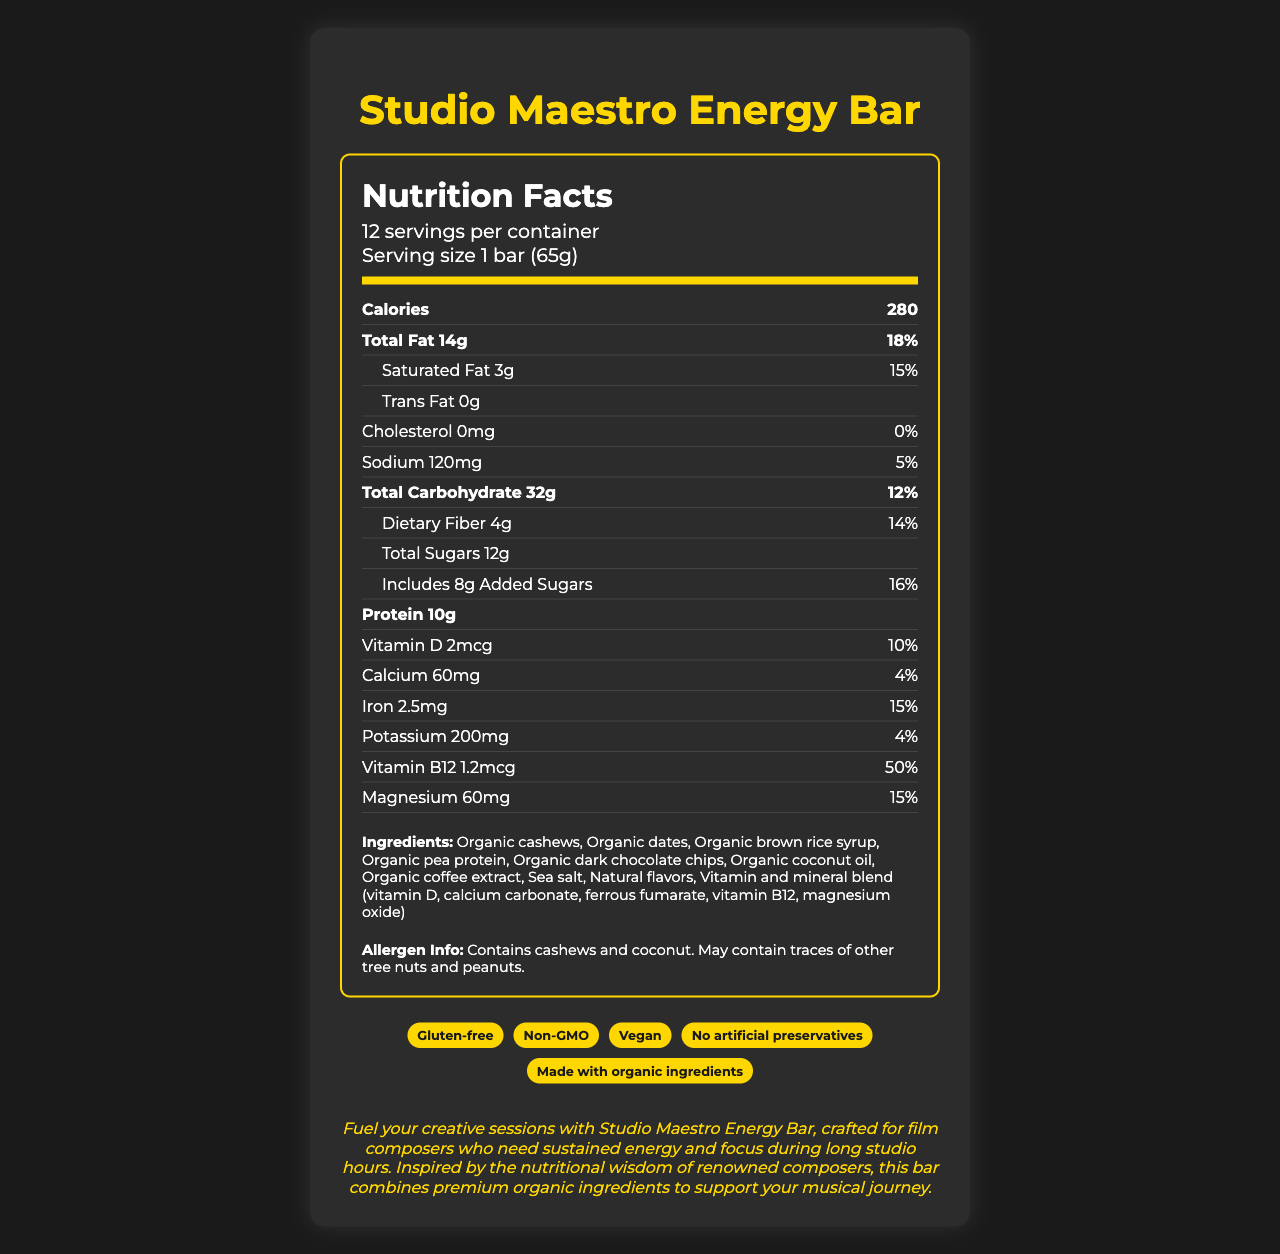What is the serving size of the Studio Maestro Energy Bar? The serving size is explicitly stated as "1 bar (65g)" under the Nutrition Facts label.
Answer: 1 bar (65g) How many servings are there per container? The Nutrition Facts label shows there are 12 servings per container.
Answer: 12 How many grams of protein does one serving contain? The amount of protein per serving is listed as "10g" in the Nutrition Facts section.
Answer: 10g What is the amount of dietary fiber per serving? The dietary fiber amount per serving is explicitly mentioned as "4g."
Answer: 4g How much added sugar is included in each serving? The amount of added sugars per serving is detailed as "8g" on the label.
Answer: 8g How many calories are in one serving? The Nutrition Facts label states that one serving contains 280 calories.
Answer: 280 How much saturated fat does the energy bar contain? A. 1g B. 3g C. 5g D. 7g The label shows that the amount of saturated fat per serving is "3g."
Answer: B. 3g Which of the following is NOT claimed on the Studio Maestro Energy Bar? A. Gluten-free B. Non-GMO C. Organic certified The claims section lists "Gluten-free," "Non-GMO," "Vegan," etc., but "Organic certified" is not listed.
Answer: C. Organic certified Is the Studio Maestro Energy Bar vegan? The claims section indicates that the product is "Vegan."
Answer: Yes Does the energy bar contain any cholesterol? The label shows "Cholesterol 0mg" and "0%" daily value.
Answer: No Summarize the main benefits and features of the Studio Maestro Energy Bar. The summary includes details from the marketing description and nutritional information, highlighting the product's purpose, ingredients, and nutritional benefits.
Answer: The Studio Maestro Energy Bar is a nutrition-rich snack designed for film composers to support long studio hours. It is made with organic ingredients and contains a balanced mix of proteins, fats, and carbohydrates. The bar is vegan, gluten-free, and non-GMO, with no artificial preservatives. It also includes several vitamins and minerals. What is the purpose of the Studio Maestro Energy Bar as described in the document? The marketing description states that the energy bar is designed to "fuel your creative sessions with Studio Maestro Energy Bar, crafted for film composers who need sustained energy and focus during long studio hours."
Answer: Fuel creative sessions with sustained energy and focus. What are the main ingredients in the Studio Maestro Energy Bar? The ingredients list explicitly mentions all these components.
Answer: Organic cashews, organic dates, organic brown rice syrup, organic pea protein, organic dark chocolate chips, organic coconut oil, organic coffee extract, sea salt, natural flavors, vitamin and mineral blend. What is the % Daily Value of Vitamin B12 in each serving? The Nutrition Facts label details that the % daily value for Vitamin B12 is 50%.
Answer: 50% How many milligrams of calcium are in each serving? The label specifies that each serving contains 60mg of calcium.
Answer: 60mg Does the energy bar contain any artificial preservatives? The claims section states "No artificial preservatives."
Answer: No What is the main idea of the document? This summarizes the detailed purpose, features, and nutritional benefits described in the document.
Answer: The document provides comprehensive nutritional information about the Studio Maestro Energy Bar, highlighting its health benefits, ingredients, and suitability for supporting long creative sessions. How much does the Studio Maestro Energy Bar cost? The document does not provide any information about the cost of the energy bar.
Answer: Cannot be determined 